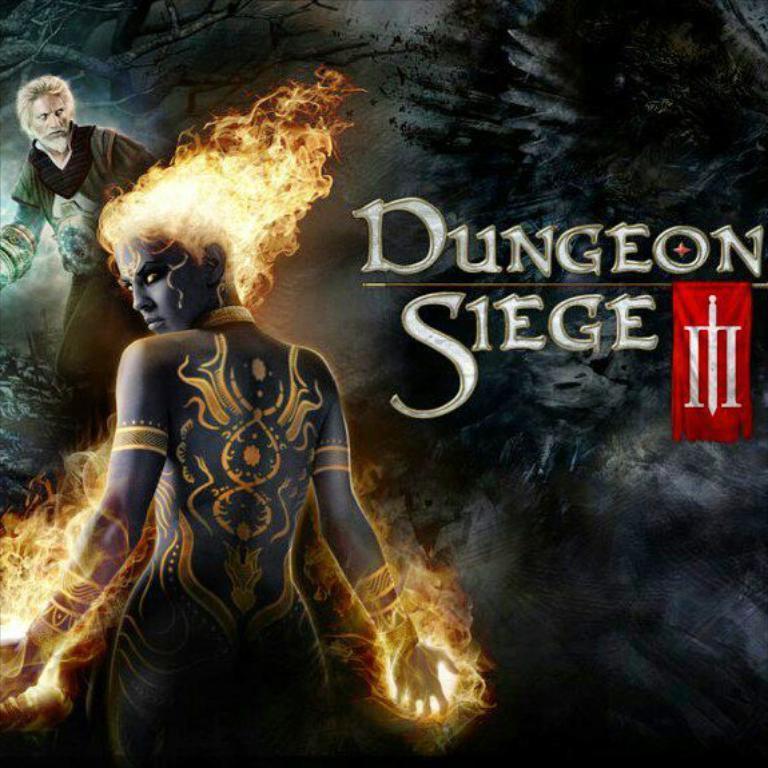Describe this image in one or two sentences. In this image I can see a person standing. Background I can see the other person wearing black jacket and I can also see something written on it. 